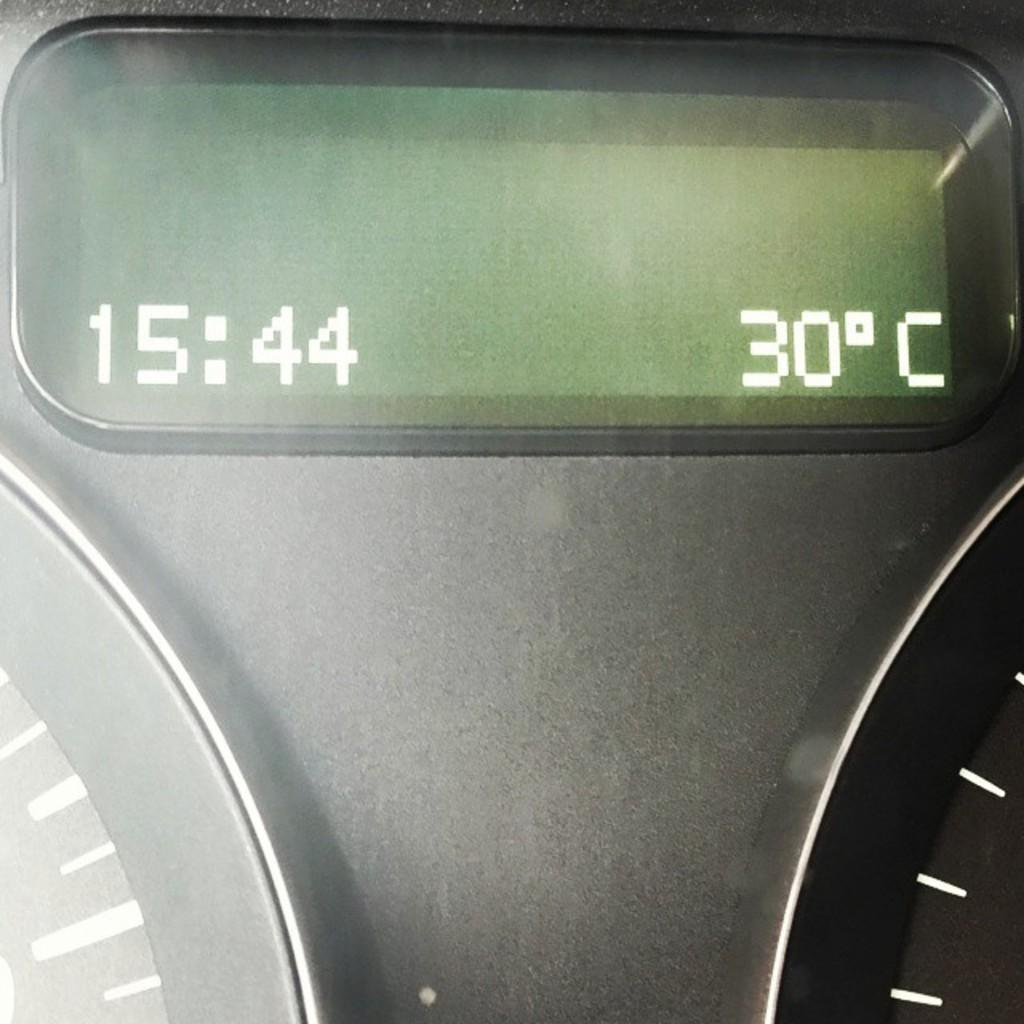<image>
Present a compact description of the photo's key features. 15:44 and 30 degrees Celcius is on a green digital car display. 